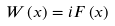<formula> <loc_0><loc_0><loc_500><loc_500>W \left ( x \right ) = i F \left ( x \right )</formula> 